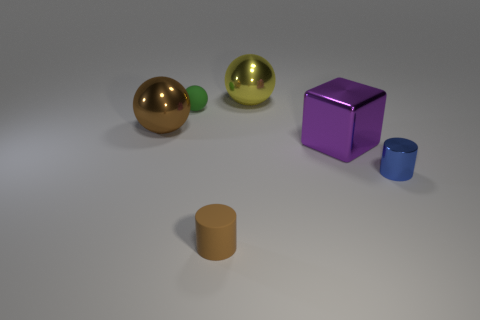Subtract all metal balls. How many balls are left? 1 Add 3 yellow spheres. How many objects exist? 9 Subtract all blue cylinders. How many cylinders are left? 1 Subtract 1 cylinders. How many cylinders are left? 1 Subtract all gray cylinders. Subtract all red blocks. How many cylinders are left? 2 Subtract all blue balls. How many yellow cylinders are left? 0 Subtract all yellow balls. Subtract all yellow objects. How many objects are left? 4 Add 5 purple metallic things. How many purple metallic things are left? 6 Add 1 blue shiny cylinders. How many blue shiny cylinders exist? 2 Subtract 0 red balls. How many objects are left? 6 